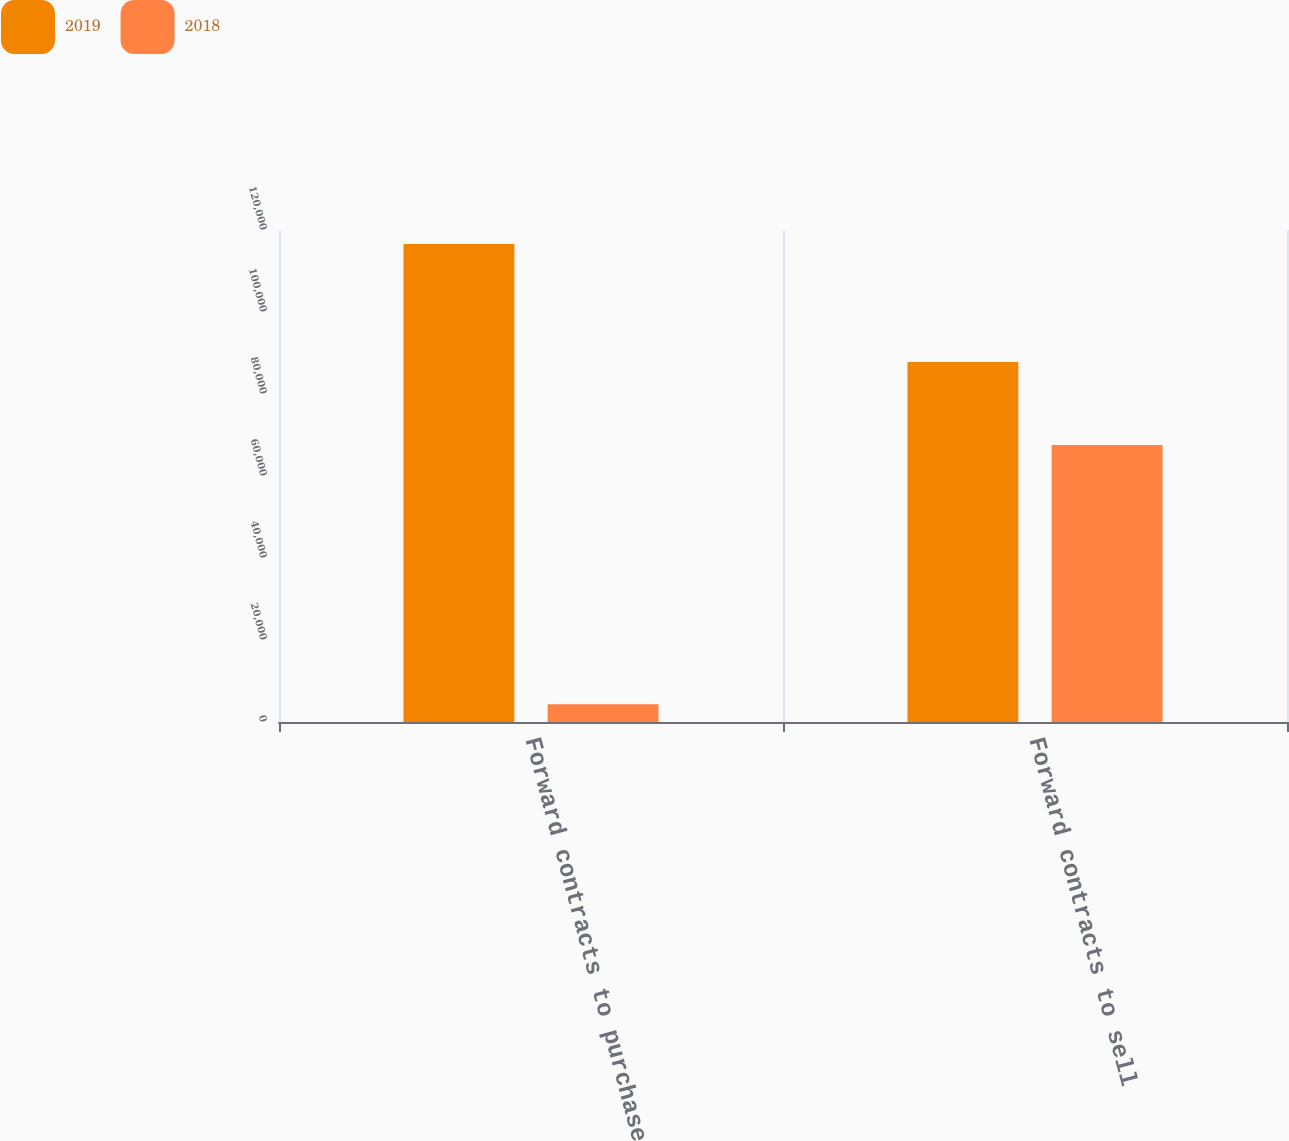<chart> <loc_0><loc_0><loc_500><loc_500><stacked_bar_chart><ecel><fcel>Forward contracts to purchase<fcel>Forward contracts to sell<nl><fcel>2019<fcel>116590<fcel>87793<nl><fcel>2018<fcel>4359<fcel>67580<nl></chart> 